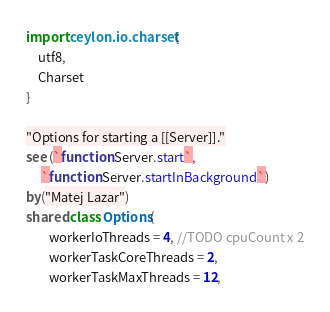<code> <loc_0><loc_0><loc_500><loc_500><_Ceylon_>import ceylon.io.charset {
    utf8,
    Charset
}

"Options for starting a [[Server]]."
see (`function Server.start`, 
     `function Server.startInBackground`)
by("Matej Lazar")
shared class Options(
        workerIoThreads = 4, //TODO cpuCount x 2
        workerTaskCoreThreads = 2, 
        workerTaskMaxThreads = 12,</code> 